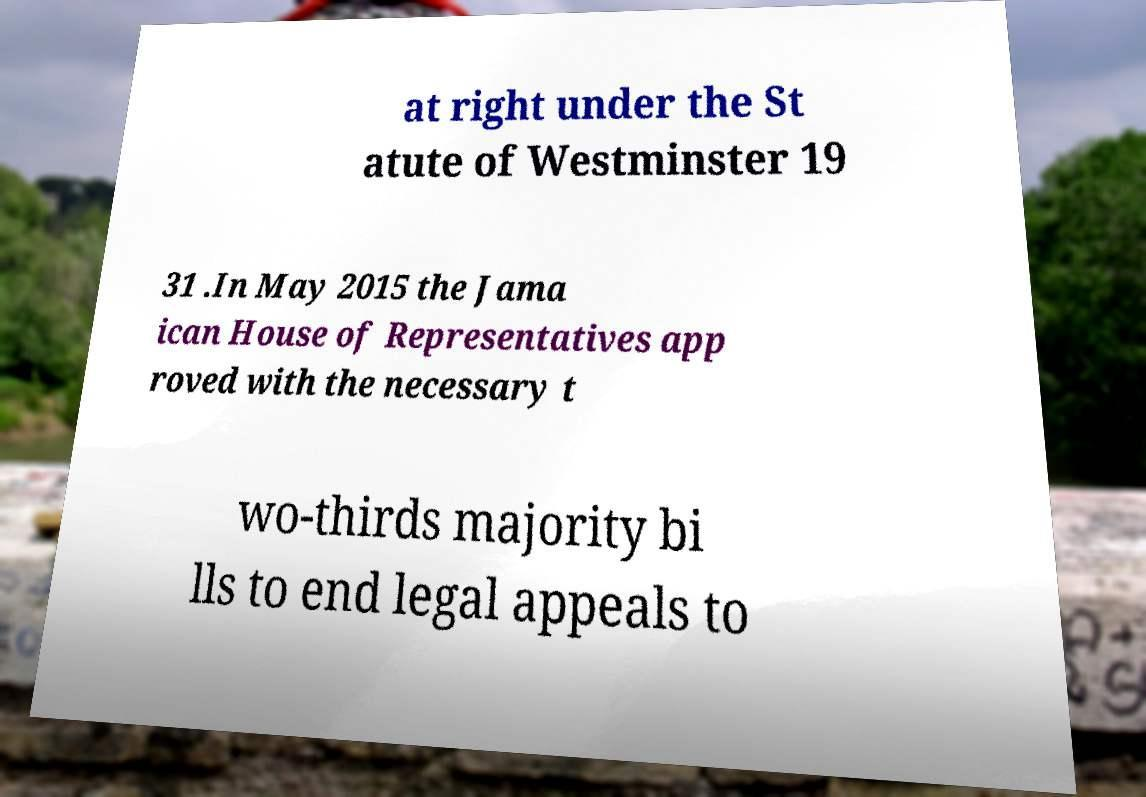Could you assist in decoding the text presented in this image and type it out clearly? at right under the St atute of Westminster 19 31 .In May 2015 the Jama ican House of Representatives app roved with the necessary t wo-thirds majority bi lls to end legal appeals to 